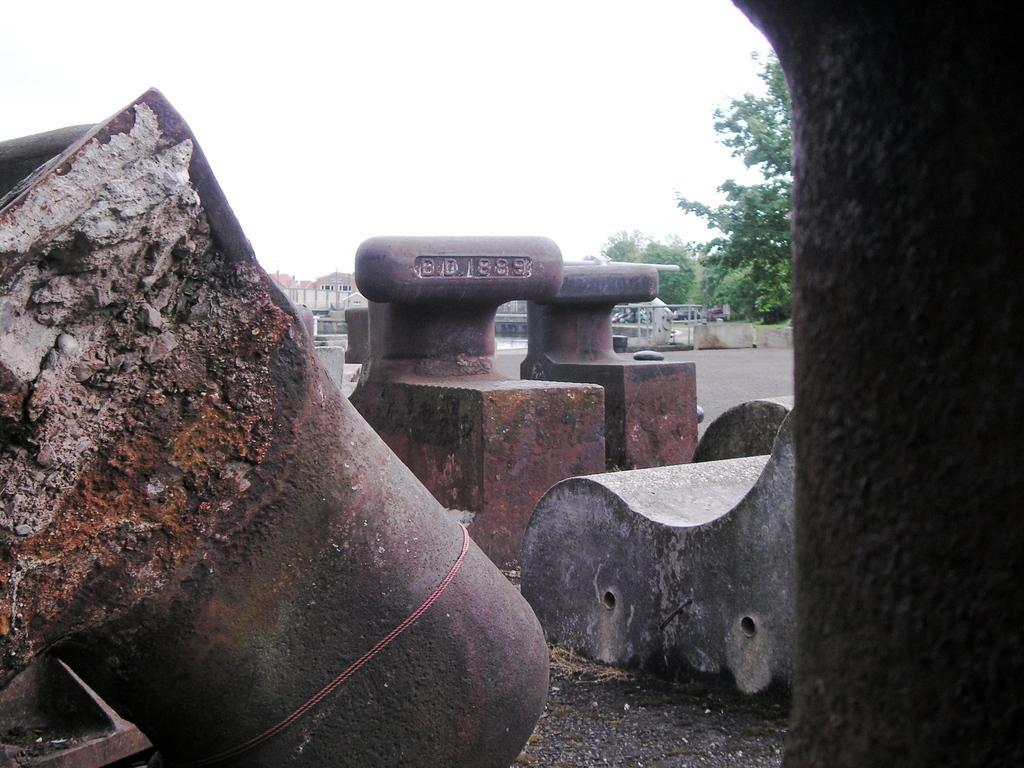Could you give a brief overview of what you see in this image? In this picture we can see a bench, some objects on the ground and in the background we can see a fence, houses, electric poles, trees, sky. 